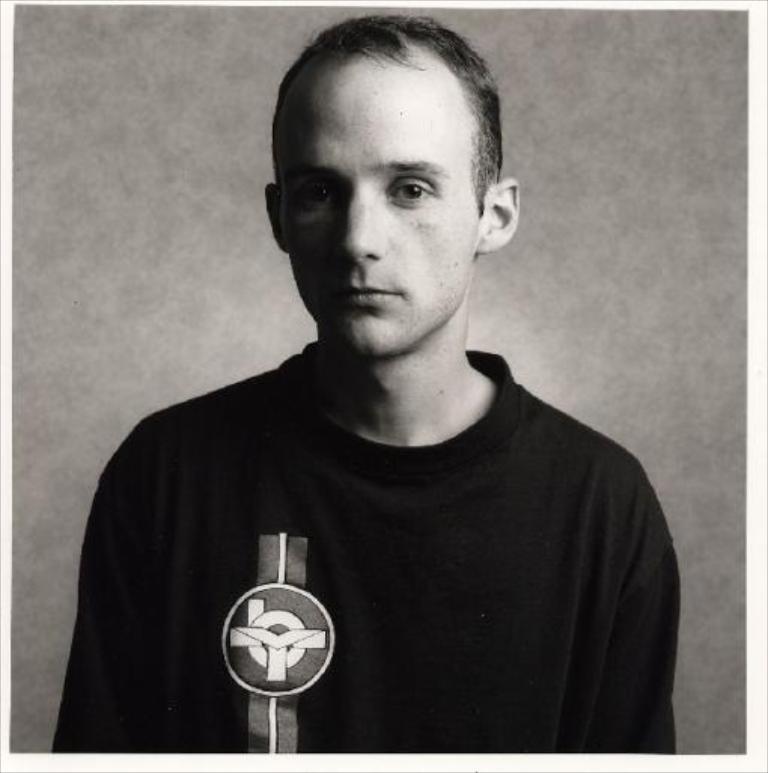Describe this image in one or two sentences. This picture shows a man. He wore a black t-shirt. 